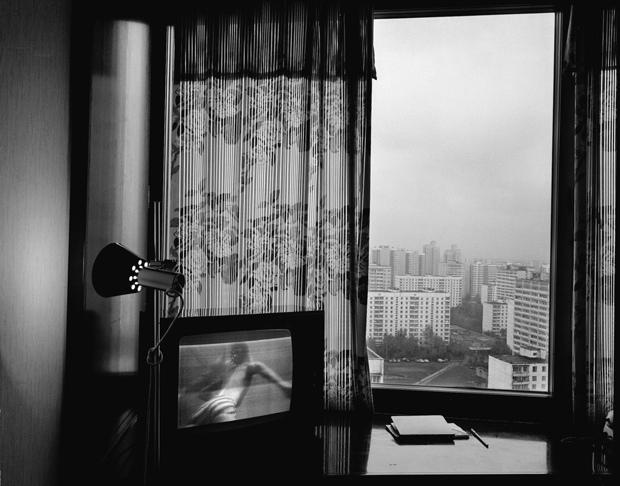What is the lamp shining on?
Answer briefly. Wall. Is the window unlocked?
Quick response, please. Yes. What is seen in the room?
Be succinct. Tv. What color curtains?
Concise answer only. Black. Is it raining outside?
Keep it brief. No. Are the curtains opaque?
Short answer required. No. 